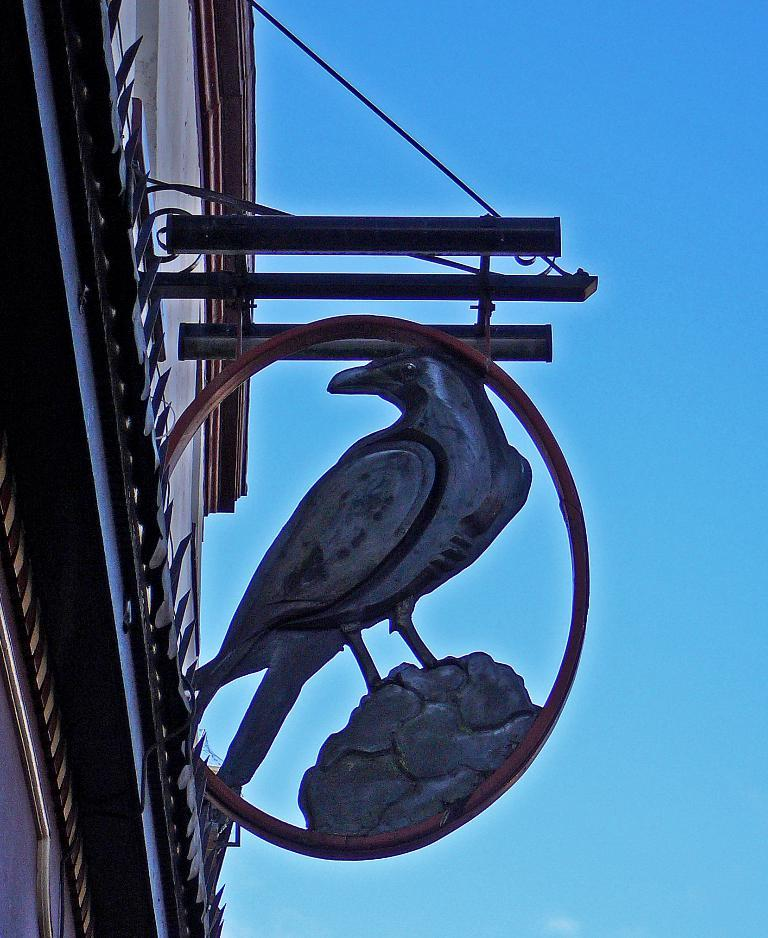What is the main subject in the image? There is a statue in the image. How is the statue supported or connected to another object? The statue is attached to a rod. What can be seen on the wall in the image? There is a wall with a design in the image. What is visible in the background of the image? The sky is visible in the background of the image. What type of pie is being divided among the people in the image? There is no pie or people present in the image; it features a statue attached to a rod, a wall with a design, and the sky in the background. 